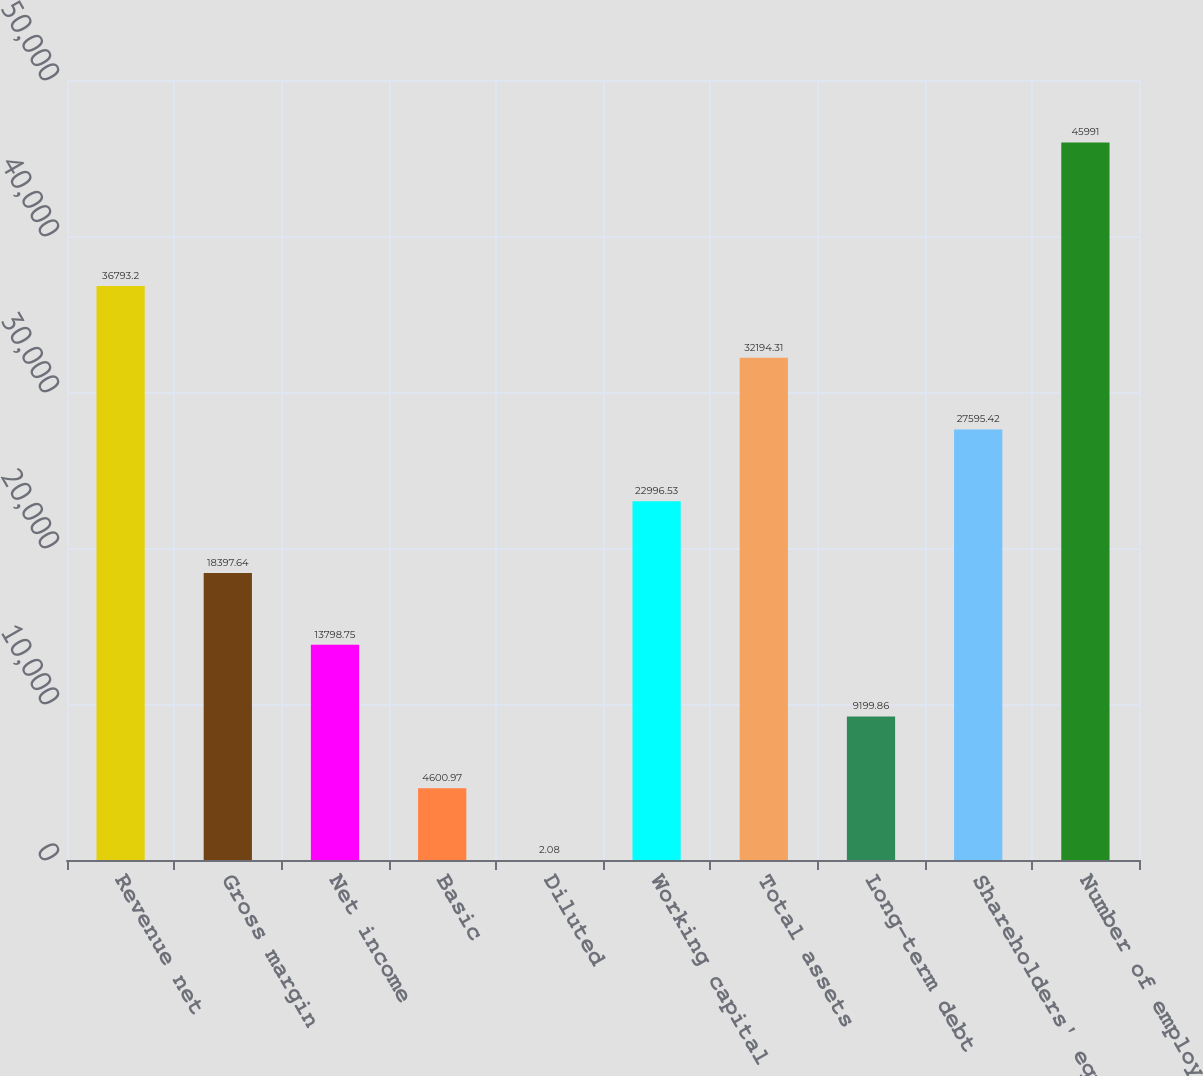Convert chart. <chart><loc_0><loc_0><loc_500><loc_500><bar_chart><fcel>Revenue net<fcel>Gross margin<fcel>Net income<fcel>Basic<fcel>Diluted<fcel>Working capital<fcel>Total assets<fcel>Long-term debt<fcel>Shareholders' equity<fcel>Number of employees<nl><fcel>36793.2<fcel>18397.6<fcel>13798.8<fcel>4600.97<fcel>2.08<fcel>22996.5<fcel>32194.3<fcel>9199.86<fcel>27595.4<fcel>45991<nl></chart> 